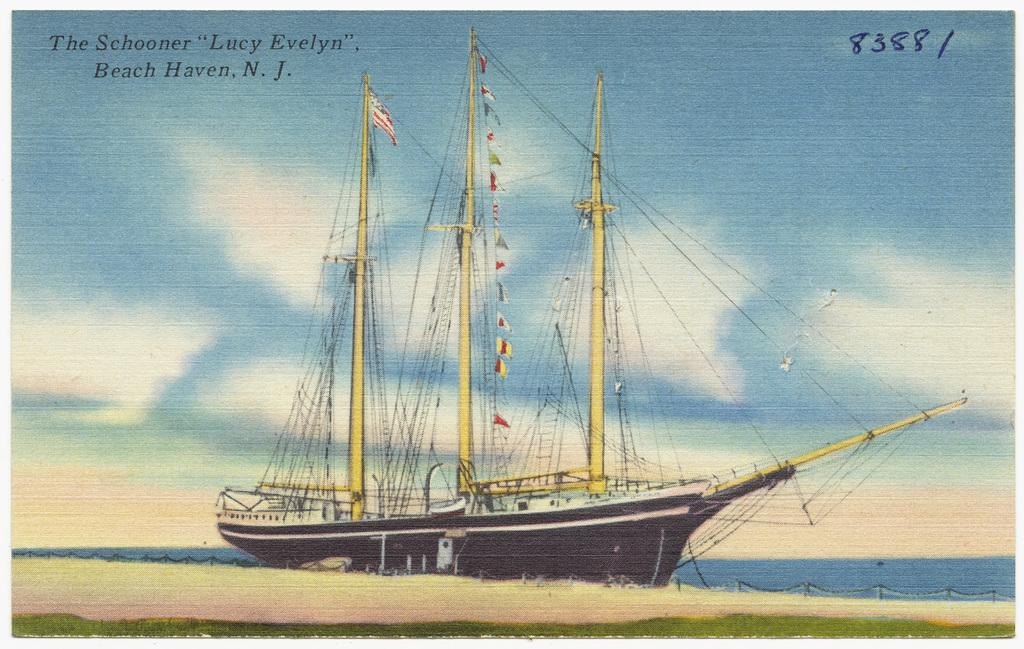What is the main subject of the painting? The painting depicts a boat in the water. Are there any other objects or structures in the painting? Yes, there is a fence in the painting. What part of the natural environment is visible in the painting? The sky is visible in the painting. What type of copper material is used to construct the boat in the painting? There is no mention of copper or any specific material used to construct the boat in the painting. The boat is simply depicted as being in the water. 